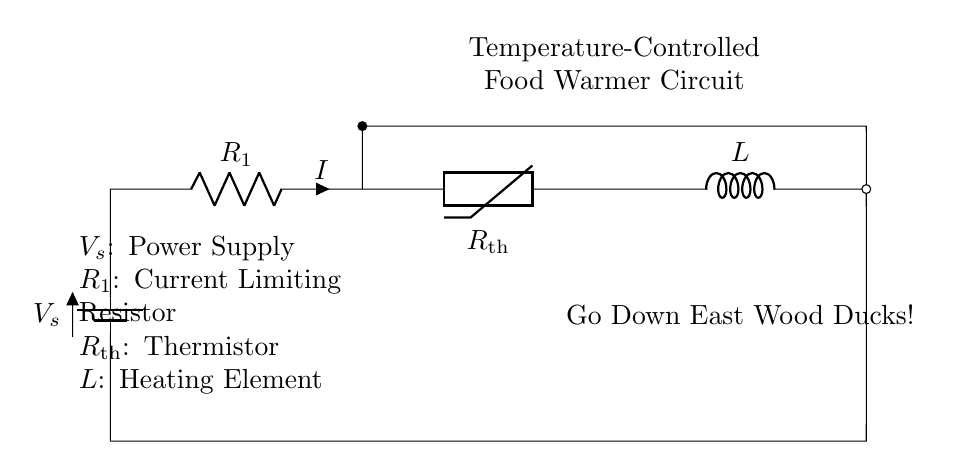What is the type of power supply used in the circuit? The circuit uses a battery as the power supply, as indicated by the symbol for the battery on the left side of the diagram.
Answer: Battery What does R1 represent in this circuit? R1 is labeled as a current limiting resistor, which is a component used to control the amount of current flowing through the circuit for safety and functionality.
Answer: Current limiting resistor What is the role of the thermistor in this circuit? The thermistor, or Rth, is a temperature-sensitive resistor that changes its resistance based on temperature, allowing for temperature control of the food warmer by affecting current flow.
Answer: Temperature sensor What is the label for the heating element? The heating element in the circuit is labeled as L, acting as the component responsible for generating heat to warm the food.
Answer: L How many main components are shown in the circuit? The circuit diagram displays a total of four main components: the power supply, current limiting resistor, thermistor, and heating element.
Answer: Four What can be inferred about the circuit’s operation related to temperature? The operation of the circuit is directly linked to temperature because the thermistor’s resistance changes with temperature, which affects the overall current and power supplied to the heating element, thus controlling its temperature.
Answer: Controls temperature 